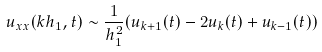Convert formula to latex. <formula><loc_0><loc_0><loc_500><loc_500>u _ { x x } ( k h _ { 1 } , t ) \sim \frac { 1 } { h _ { 1 } ^ { 2 } } ( u _ { k + 1 } ( t ) - 2 u _ { k } ( t ) + u _ { k - 1 } ( t ) )</formula> 